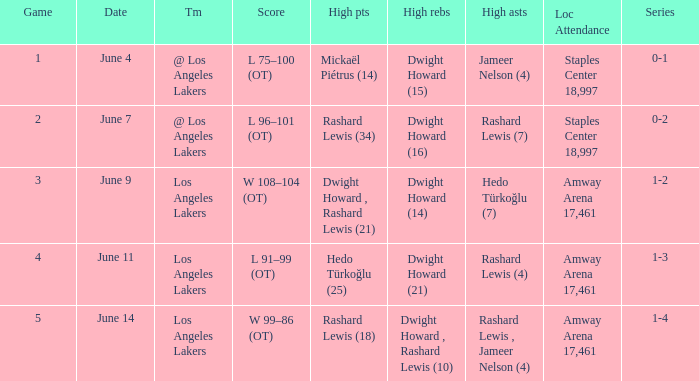What is High Points, when High Rebounds is "Dwight Howard (16)"? Rashard Lewis (34). 